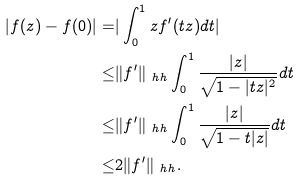Convert formula to latex. <formula><loc_0><loc_0><loc_500><loc_500>| f ( z ) - f ( 0 ) | = & | \int _ { 0 } ^ { 1 } z f ^ { \prime } ( t z ) d t | \\ \leq & \| f ^ { \prime } \| _ { \ h h } \int _ { 0 } ^ { 1 } \frac { | z | } { \sqrt { 1 - | t z | ^ { 2 } } } d t \\ \leq & \| f ^ { \prime } \| _ { \ h h } \int _ { 0 } ^ { 1 } \frac { | z | } { \sqrt { 1 - t | z | } } d t \\ \leq & 2 \| f ^ { \prime } \| _ { \ h h } .</formula> 